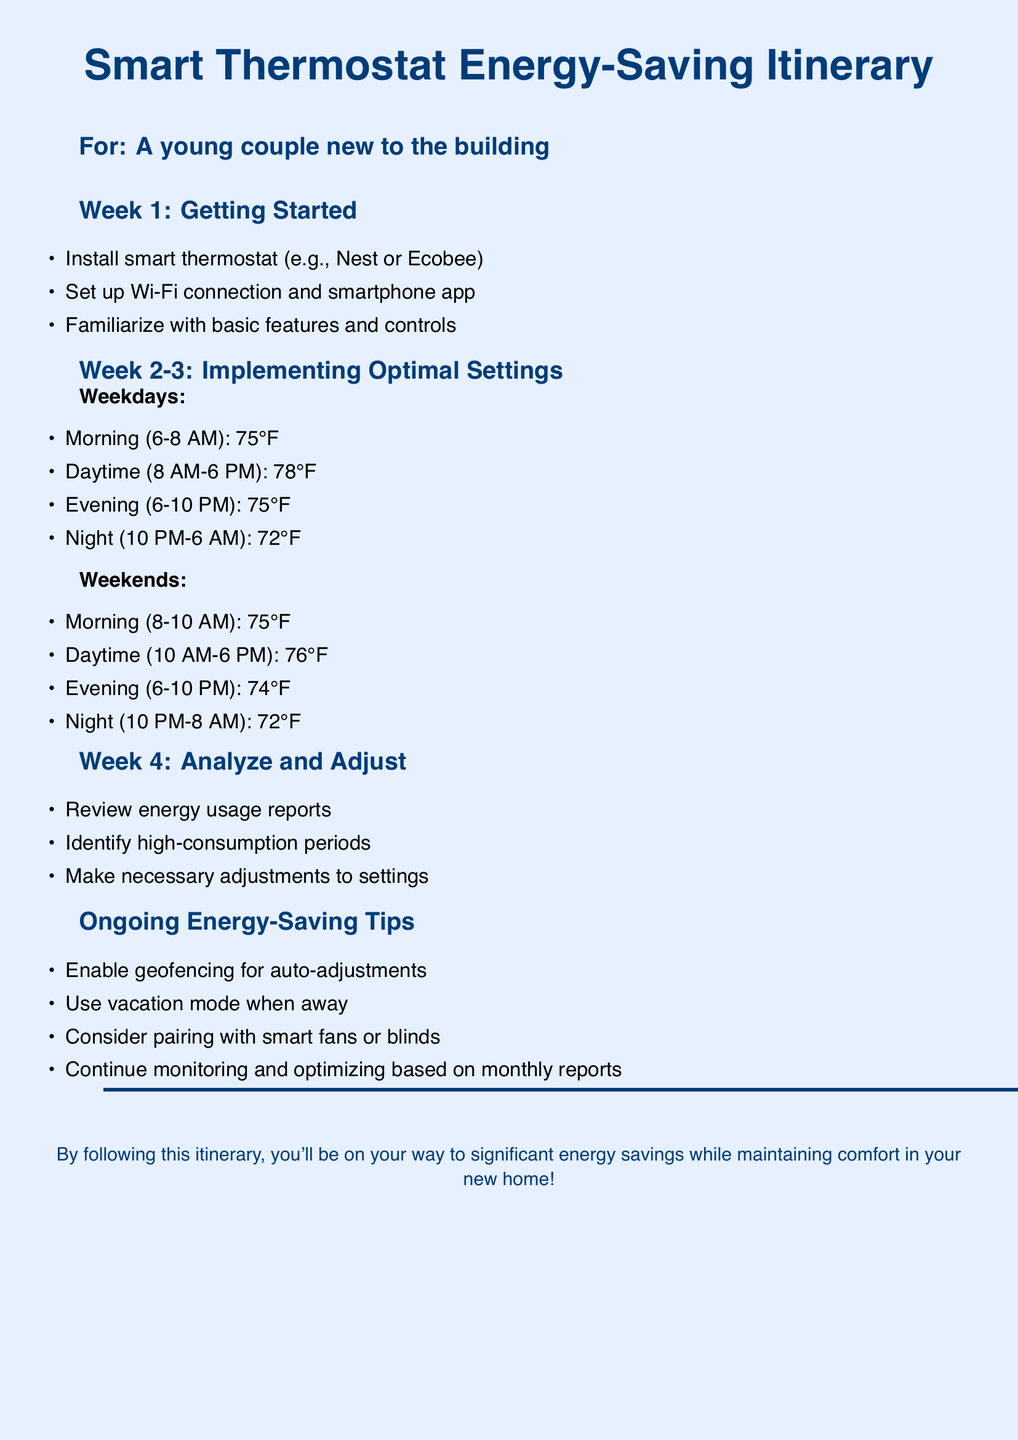What is the first task in Week 1? The first task listed in Week 1 is "Install smart thermostat (e.g., Nest or Ecobee)."
Answer: Install smart thermostat (e.g., Nest or Ecobee) What temperature is set for nighttime during weekdays? The temperature set for nighttime during weekdays (10 PM-6 AM) is 72°F.
Answer: 72°F How many weeks does the itinerary cover? The itinerary explicitly outlines activities for four weeks, from getting started to analyzing and adjusting settings.
Answer: Four weeks What is one ongoing energy-saving tip mentioned in the document? The document lists several tips, one of which is to "Enable geofencing for auto-adjustments."
Answer: Enable geofencing for auto-adjustments What temperature is recommended during daytime on weekends? The recommendation for daytime temperature on weekends (10 AM-6 PM) is 76°F.
Answer: 76°F In which week should you review energy usage reports? The review of energy usage reports is scheduled for Week 4.
Answer: Week 4 How often should you monitor and optimize settings? The document suggests that you should continue monitoring and optimizing based on monthly reports.
Answer: Monthly What is the recommended temperature for evenings on weekdays? The recommended temperature for evenings on weekdays (6-10 PM) is 75°F.
Answer: 75°F What is a function of geofencing according to the document? The document states that geofencing allows for auto-adjustments when you are away from home.
Answer: Auto-adjustments 